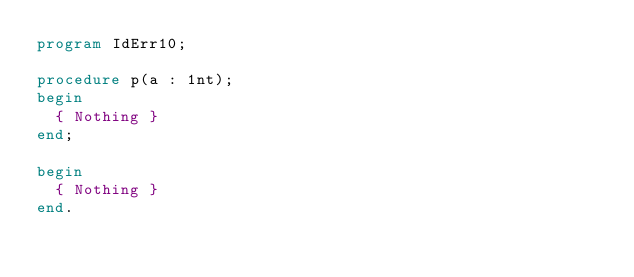Convert code to text. <code><loc_0><loc_0><loc_500><loc_500><_Pascal_>program IdErr10;

procedure p(a : 1nt);
begin
	{ Nothing }
end;

begin
	{ Nothing }
end.</code> 